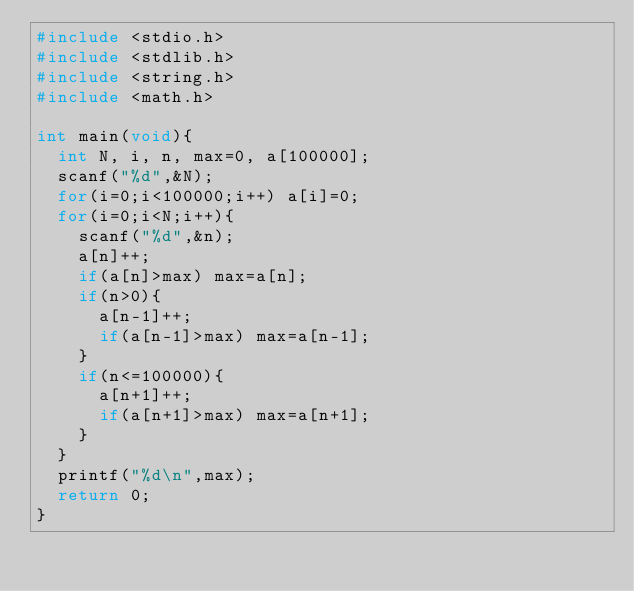<code> <loc_0><loc_0><loc_500><loc_500><_C_>#include <stdio.h>
#include <stdlib.h>
#include <string.h>
#include <math.h>

int main(void){
  int N, i, n, max=0, a[100000];
  scanf("%d",&N);
  for(i=0;i<100000;i++) a[i]=0;
  for(i=0;i<N;i++){
    scanf("%d",&n);
    a[n]++;
    if(a[n]>max) max=a[n];
    if(n>0){
      a[n-1]++;
      if(a[n-1]>max) max=a[n-1];
    }
    if(n<=100000){
      a[n+1]++;
      if(a[n+1]>max) max=a[n+1];
    }    
  }
  printf("%d\n",max);
  return 0;
}
</code> 